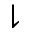<formula> <loc_0><loc_0><loc_500><loc_500>\downharpoonright</formula> 